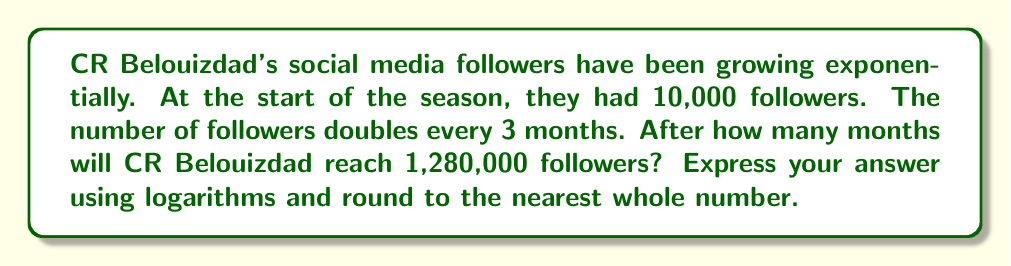Show me your answer to this math problem. Let's approach this step-by-step:

1) Let $x$ be the number of months we're looking for.

2) We can express this problem as an exponential equation:
   $10,000 \cdot 2^{\frac{x}{3}} = 1,280,000$

3) Divide both sides by 10,000:
   $2^{\frac{x}{3}} = 128$

4) Now, we can apply logarithms to both sides. Let's use log base 2:
   $\log_2(2^{\frac{x}{3}}) = \log_2(128)$

5) Using the logarithm property $\log_a(a^x) = x$, we get:
   $\frac{x}{3} = \log_2(128)$

6) Multiply both sides by 3:
   $x = 3 \cdot \log_2(128)$

7) We can calculate $\log_2(128)$:
   $128 = 2^7$, so $\log_2(128) = 7$

8) Therefore:
   $x = 3 \cdot 7 = 21$

Thus, it will take 21 months for CR Belouizdad to reach 1,280,000 followers.
Answer: $x = 3 \cdot \log_2(128) = 21$ months 